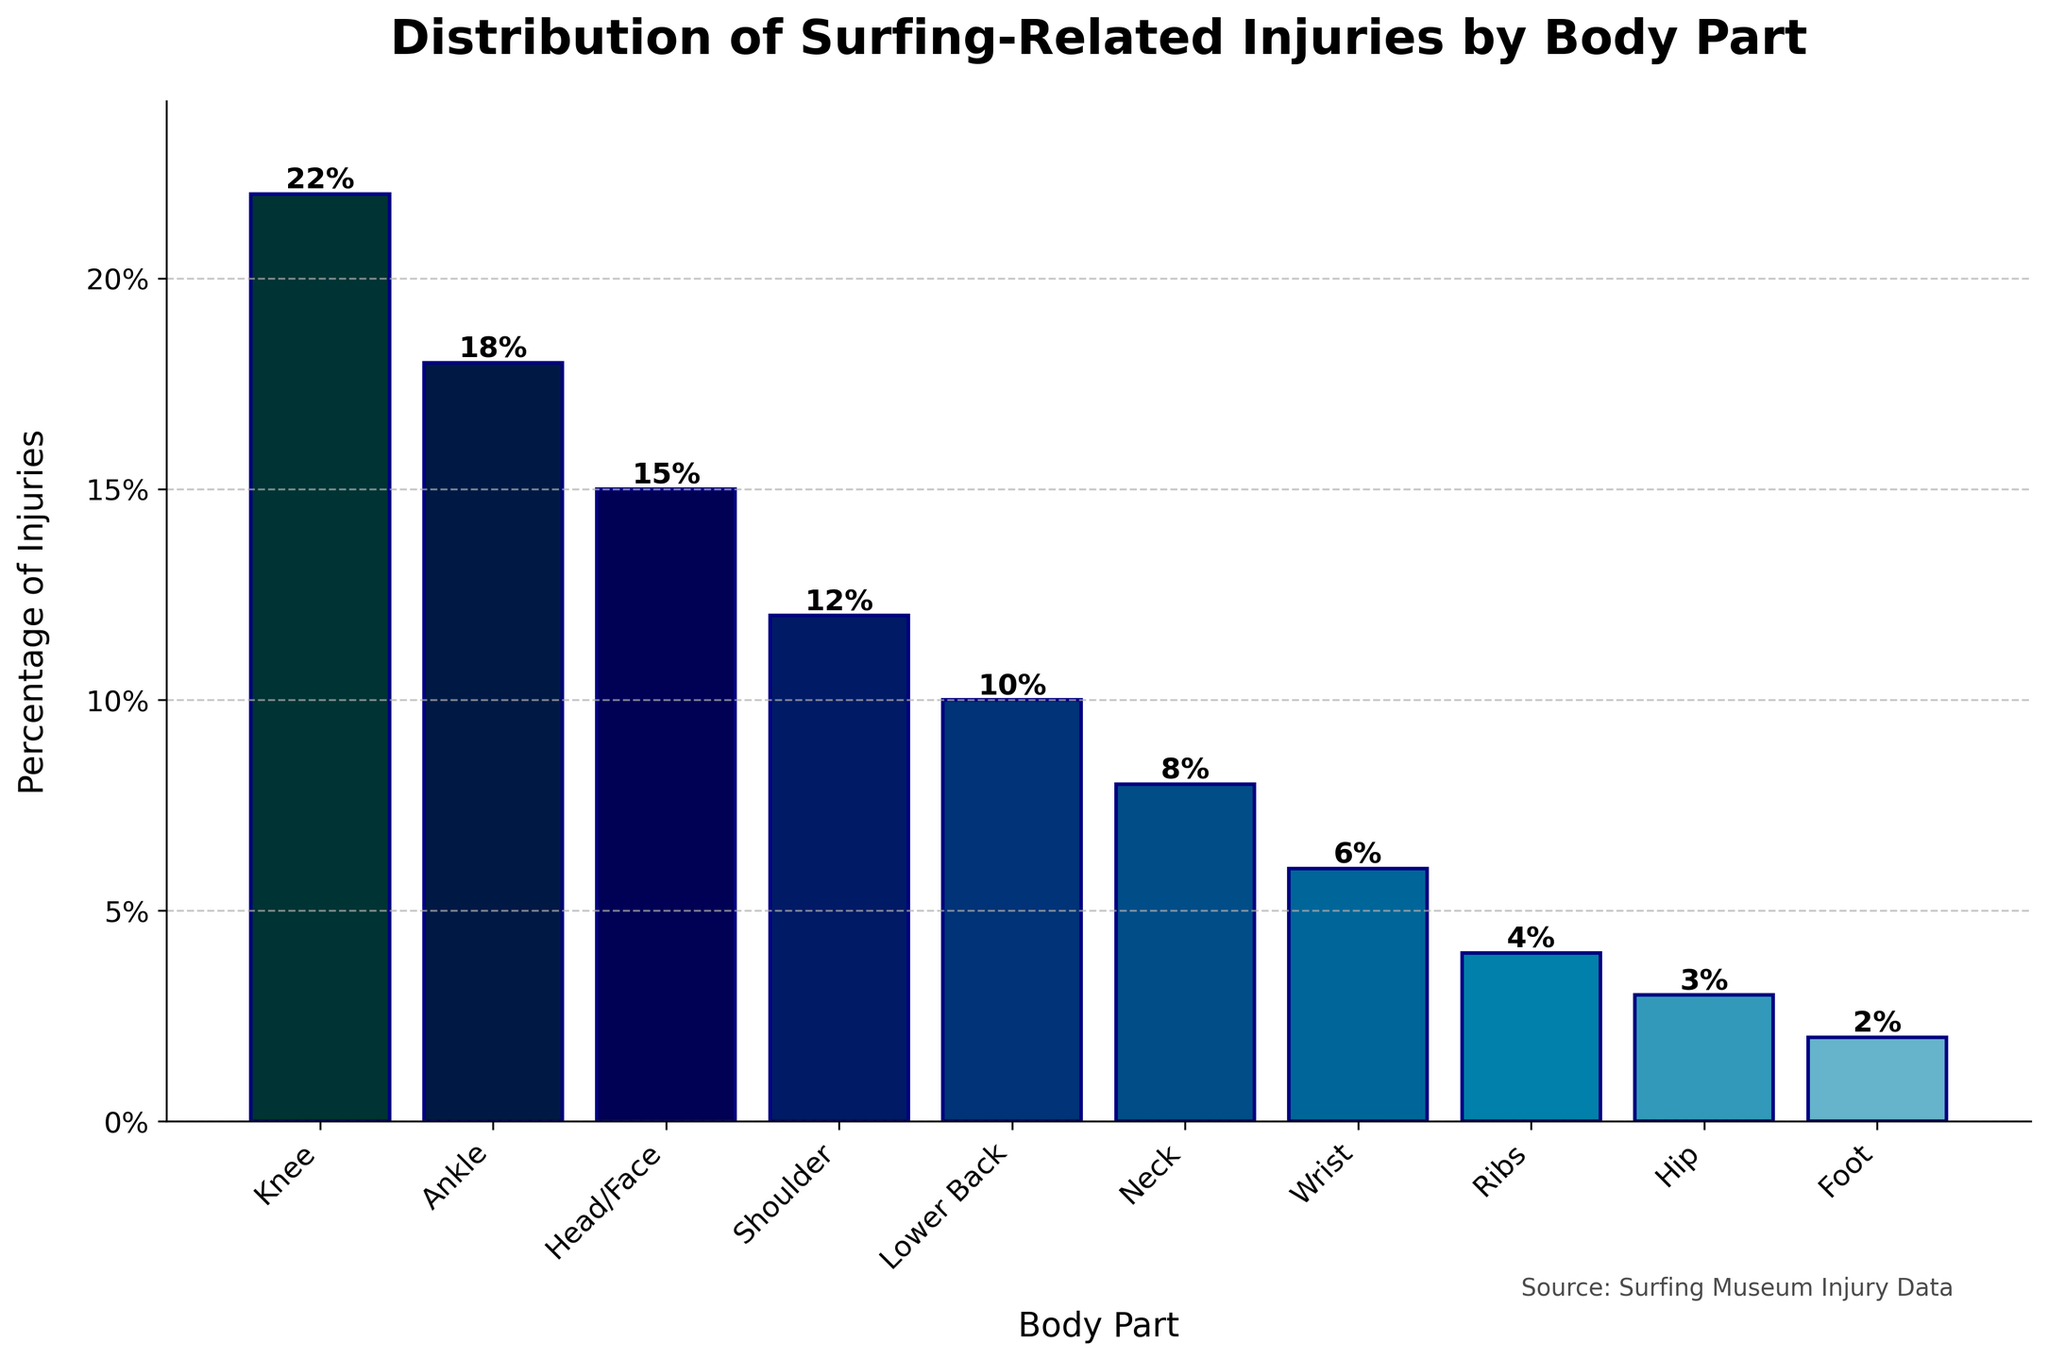What's the most common body part injured in surfing? The tallest bar represents the most common body part injured, which is the knee at 22%.
Answer: The knee Which injury is more common, ankle or shoulder, and by how much? Look at the heights of both bars: the ankle (18%) and the shoulder (12%). Subtract the lower percentage from the higher one. 18% - 12% = 6%.
Answer: Ankle by 6% What's the combined percentage of injuries affecting the lower back and the neck? Add the percentages of lower back (10%) and neck (8%). 10% + 8% = 18%.
Answer: 18% What body parts have injury percentages below 5%? Identify the bars with heights representing percentages below 5%. The hip and foot have percentages of 3% and 2%, respectively.
Answer: Hip, Foot Which injury is less common, wrist or ribs, and by how much? Compare the heights of the bars for the wrist (6%) and ribs (4%). Subtract the smaller percentage from the larger one. 6% - 4% = 2%.
Answer: Ribs by 2% What's the average percentage of injuries for the shoulder, wrist, and hip? Sum the percentages of the shoulder (12%), wrist (6%), and hip (3%) and divide by 3. (12 + 6 + 3) / 3 = 21 / 3 = 7%.
Answer: 7% Which three body parts have the highest injury percentages? Identify the three tallest bars representing the highest percentages: knee (22%), ankle (18%), and head/face (15%).
Answer: Knee, Ankle, Head/Face By how much does the percentage of knee injuries exceed that of hip injuries? Subtract the percentage of hip injuries (3%) from the percentage of knee injuries (22%). 22% - 3% = 19%.
Answer: 19% If we consider the sum of ankle and knee injuries, what percentage of the total does it represent? Sum the percentages of ankle and knee injuries (18% + 22%) = 40%.
Answer: 40% Is the percentage of head/face injuries higher than neck injuries, and by how much? Compare the heights of the bars for head/face (15%) and neck (8%). Subtract the smaller percentage from the larger one. 15% - 8% = 7%.
Answer: Yes, by 7% 